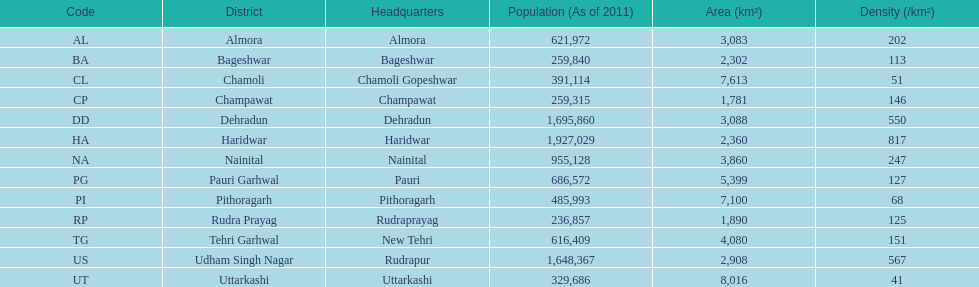Above "cl", which code is present? BA. 